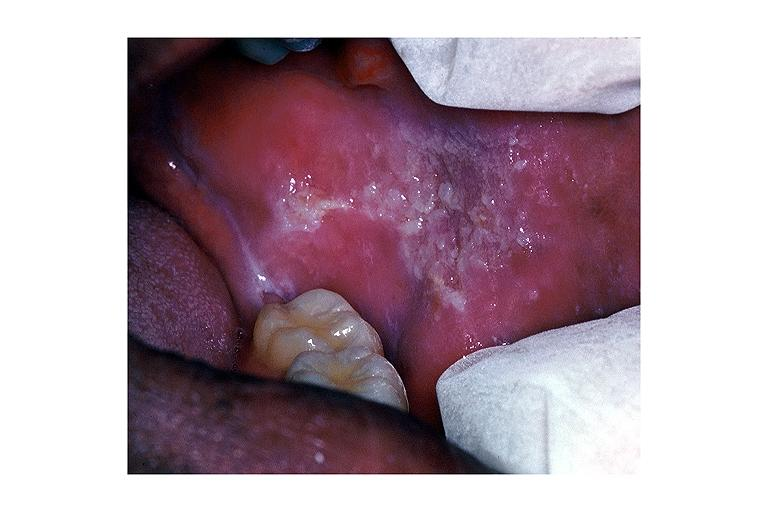s oral present?
Answer the question using a single word or phrase. Yes 